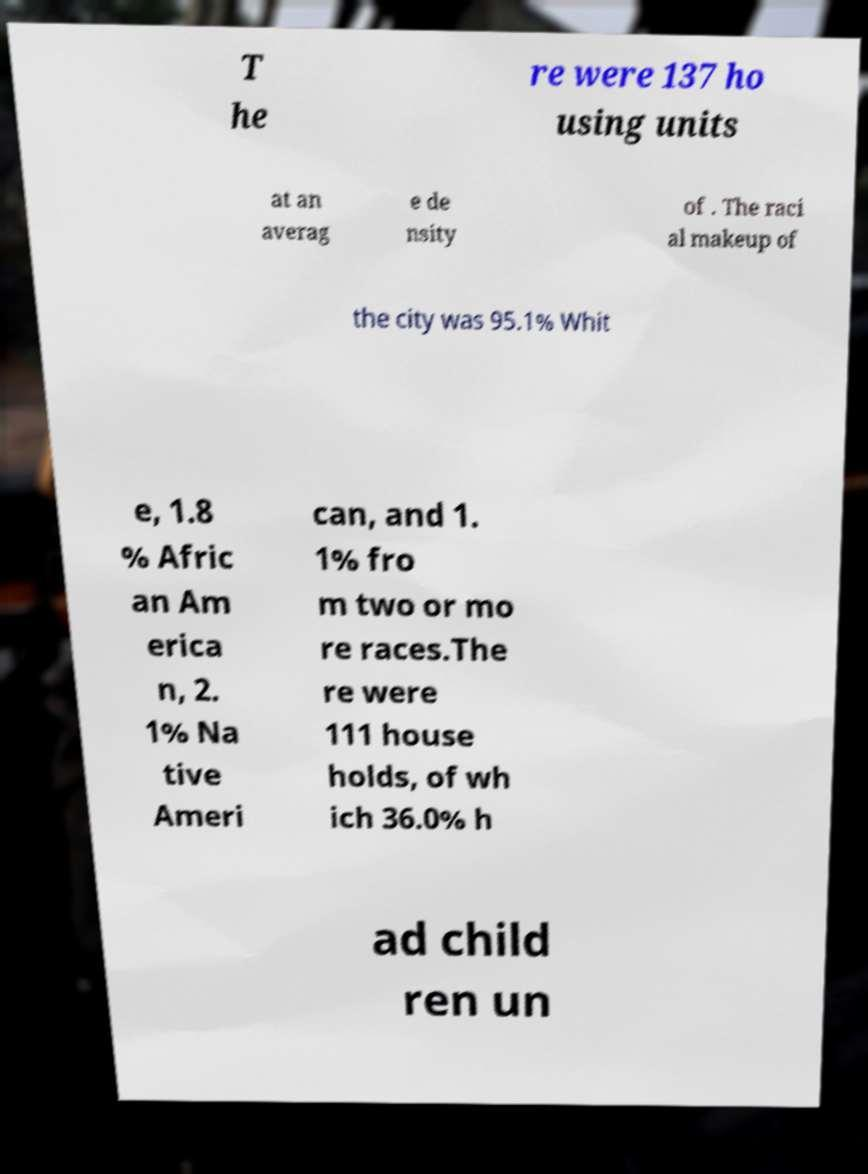Can you read and provide the text displayed in the image?This photo seems to have some interesting text. Can you extract and type it out for me? T he re were 137 ho using units at an averag e de nsity of . The raci al makeup of the city was 95.1% Whit e, 1.8 % Afric an Am erica n, 2. 1% Na tive Ameri can, and 1. 1% fro m two or mo re races.The re were 111 house holds, of wh ich 36.0% h ad child ren un 